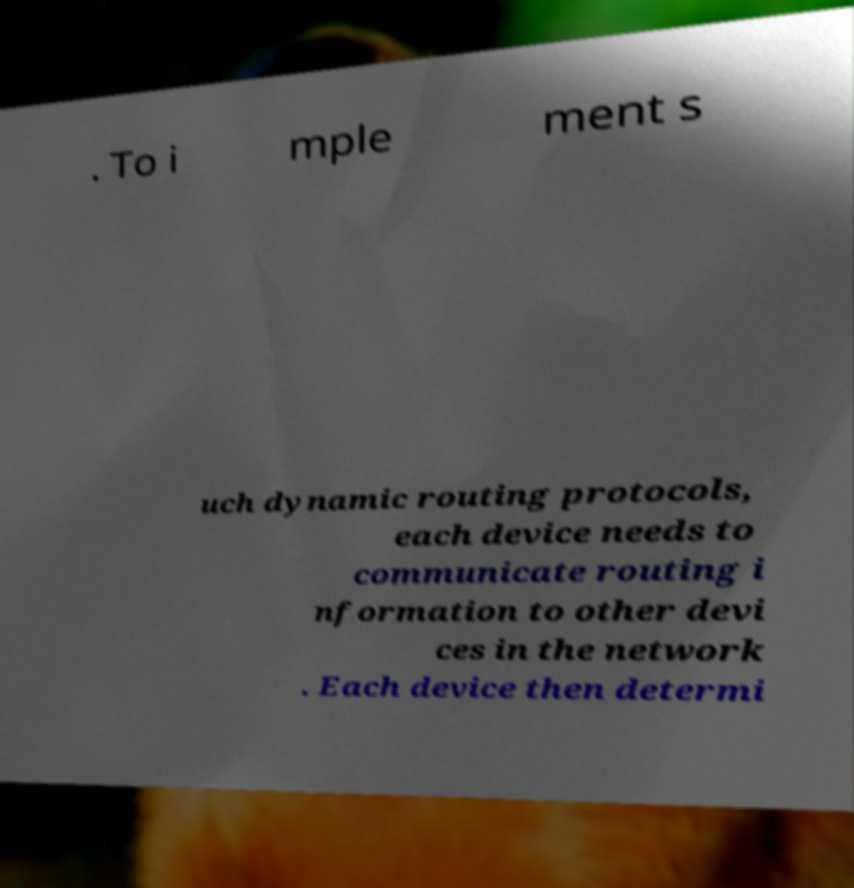Could you assist in decoding the text presented in this image and type it out clearly? . To i mple ment s uch dynamic routing protocols, each device needs to communicate routing i nformation to other devi ces in the network . Each device then determi 